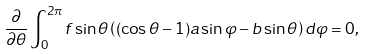Convert formula to latex. <formula><loc_0><loc_0><loc_500><loc_500>\frac { \partial } { \partial \theta } \int _ { 0 } ^ { 2 \pi } f \sin \theta \left ( ( \cos \theta - 1 ) a \sin \varphi - b \sin \theta \right ) d \varphi = 0 ,</formula> 